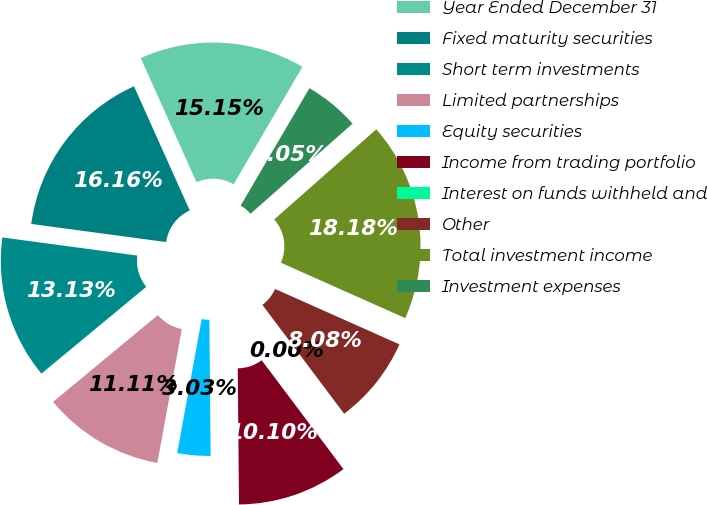Convert chart to OTSL. <chart><loc_0><loc_0><loc_500><loc_500><pie_chart><fcel>Year Ended December 31<fcel>Fixed maturity securities<fcel>Short term investments<fcel>Limited partnerships<fcel>Equity securities<fcel>Income from trading portfolio<fcel>Interest on funds withheld and<fcel>Other<fcel>Total investment income<fcel>Investment expenses<nl><fcel>15.15%<fcel>16.16%<fcel>13.13%<fcel>11.11%<fcel>3.03%<fcel>10.1%<fcel>0.0%<fcel>8.08%<fcel>18.18%<fcel>5.05%<nl></chart> 